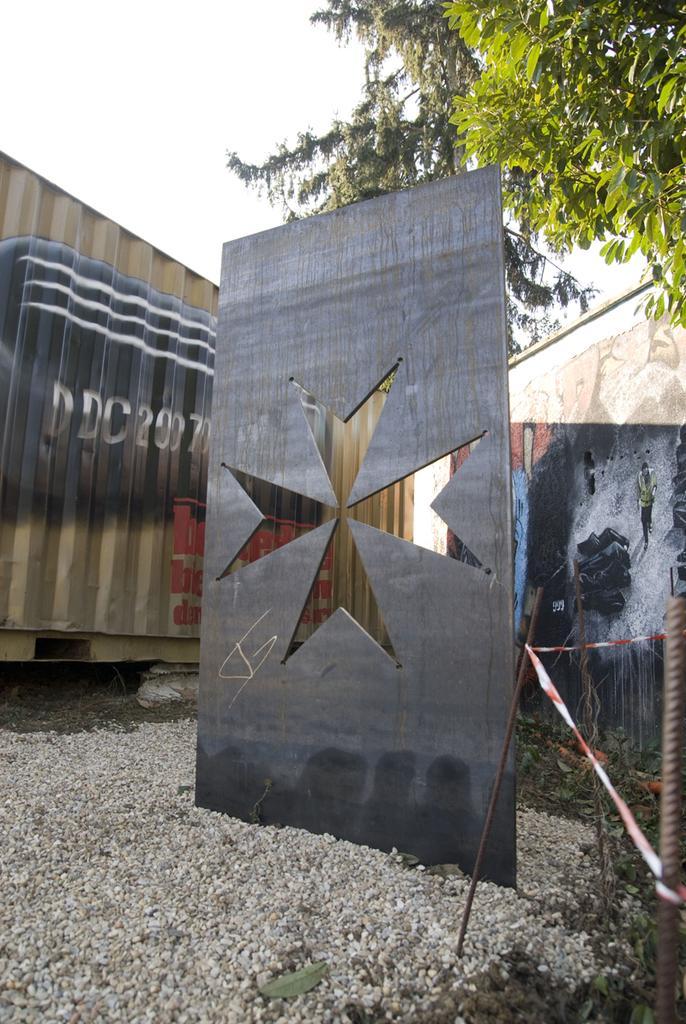Describe this image in one or two sentences. In the foreground of the picture there are stones, plants, iron rods, ribbon and a board. In the background there are wall, container. On the wall and container there is graffiti. At the top there are trees. Sky is cloudy. 